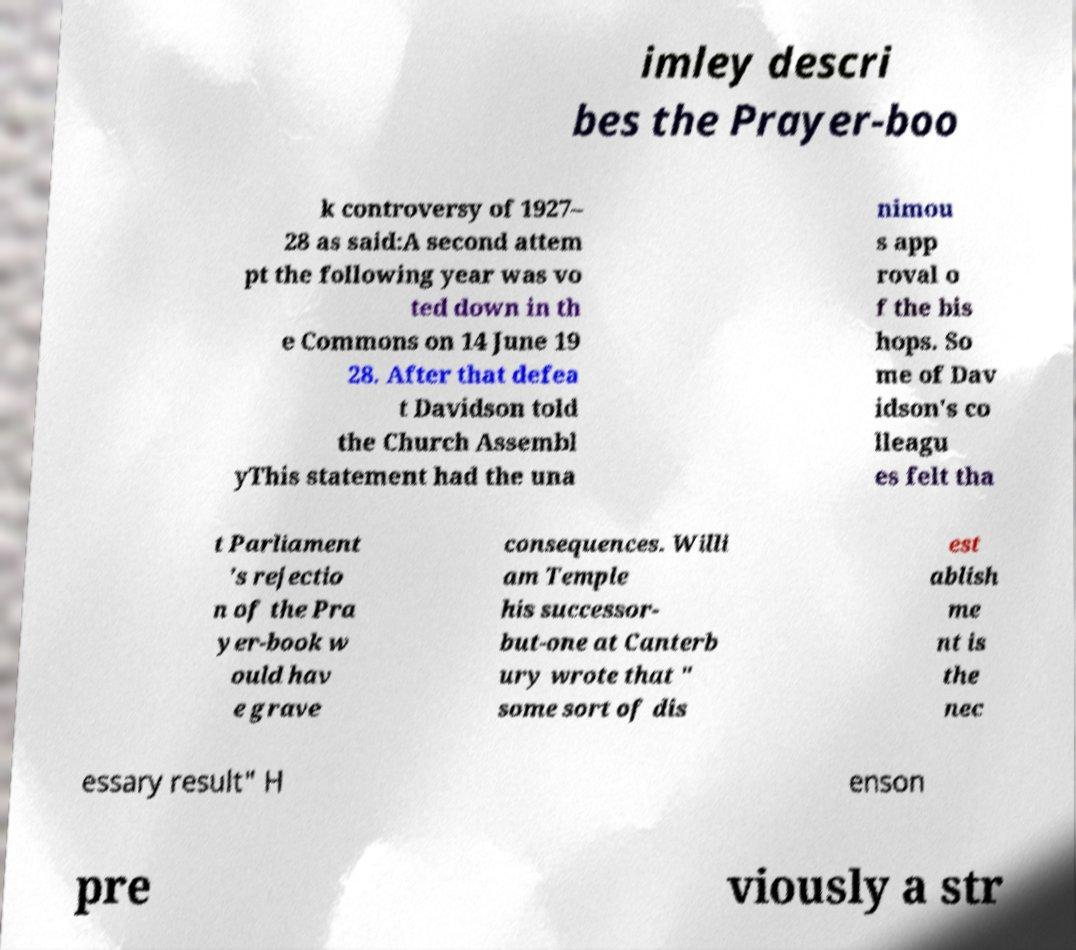Can you read and provide the text displayed in the image?This photo seems to have some interesting text. Can you extract and type it out for me? imley descri bes the Prayer-boo k controversy of 1927– 28 as said:A second attem pt the following year was vo ted down in th e Commons on 14 June 19 28. After that defea t Davidson told the Church Assembl yThis statement had the una nimou s app roval o f the bis hops. So me of Dav idson's co lleagu es felt tha t Parliament 's rejectio n of the Pra yer-book w ould hav e grave consequences. Willi am Temple his successor- but-one at Canterb ury wrote that " some sort of dis est ablish me nt is the nec essary result" H enson pre viously a str 